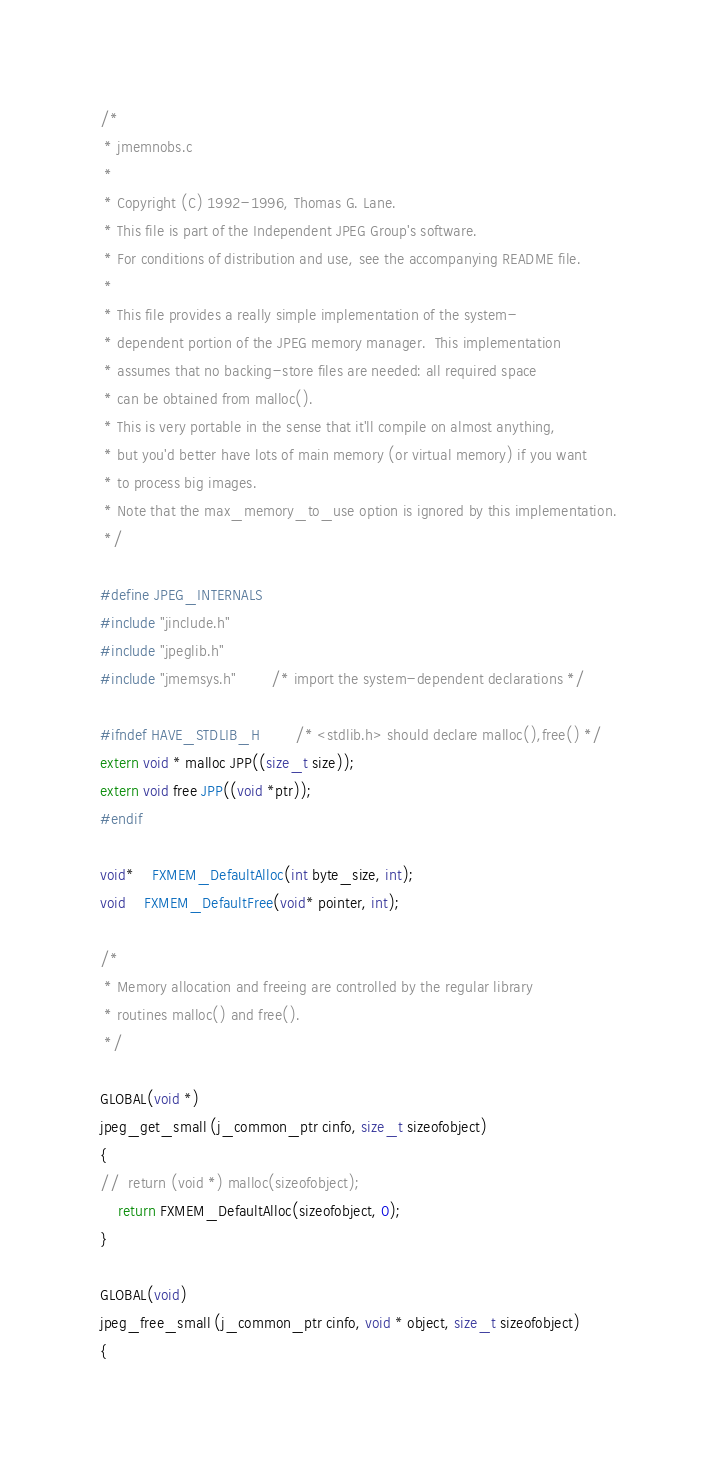Convert code to text. <code><loc_0><loc_0><loc_500><loc_500><_C_>/*
 * jmemnobs.c
 *
 * Copyright (C) 1992-1996, Thomas G. Lane.
 * This file is part of the Independent JPEG Group's software.
 * For conditions of distribution and use, see the accompanying README file.
 *
 * This file provides a really simple implementation of the system-
 * dependent portion of the JPEG memory manager.  This implementation
 * assumes that no backing-store files are needed: all required space
 * can be obtained from malloc().
 * This is very portable in the sense that it'll compile on almost anything,
 * but you'd better have lots of main memory (or virtual memory) if you want
 * to process big images.
 * Note that the max_memory_to_use option is ignored by this implementation.
 */

#define JPEG_INTERNALS
#include "jinclude.h"
#include "jpeglib.h"
#include "jmemsys.h"		/* import the system-dependent declarations */

#ifndef HAVE_STDLIB_H		/* <stdlib.h> should declare malloc(),free() */
extern void * malloc JPP((size_t size));
extern void free JPP((void *ptr));
#endif

void*	FXMEM_DefaultAlloc(int byte_size, int);
void	FXMEM_DefaultFree(void* pointer, int);

/*
 * Memory allocation and freeing are controlled by the regular library
 * routines malloc() and free().
 */

GLOBAL(void *)
jpeg_get_small (j_common_ptr cinfo, size_t sizeofobject)
{
//  return (void *) malloc(sizeofobject);
	return FXMEM_DefaultAlloc(sizeofobject, 0);
}

GLOBAL(void)
jpeg_free_small (j_common_ptr cinfo, void * object, size_t sizeofobject)
{</code> 